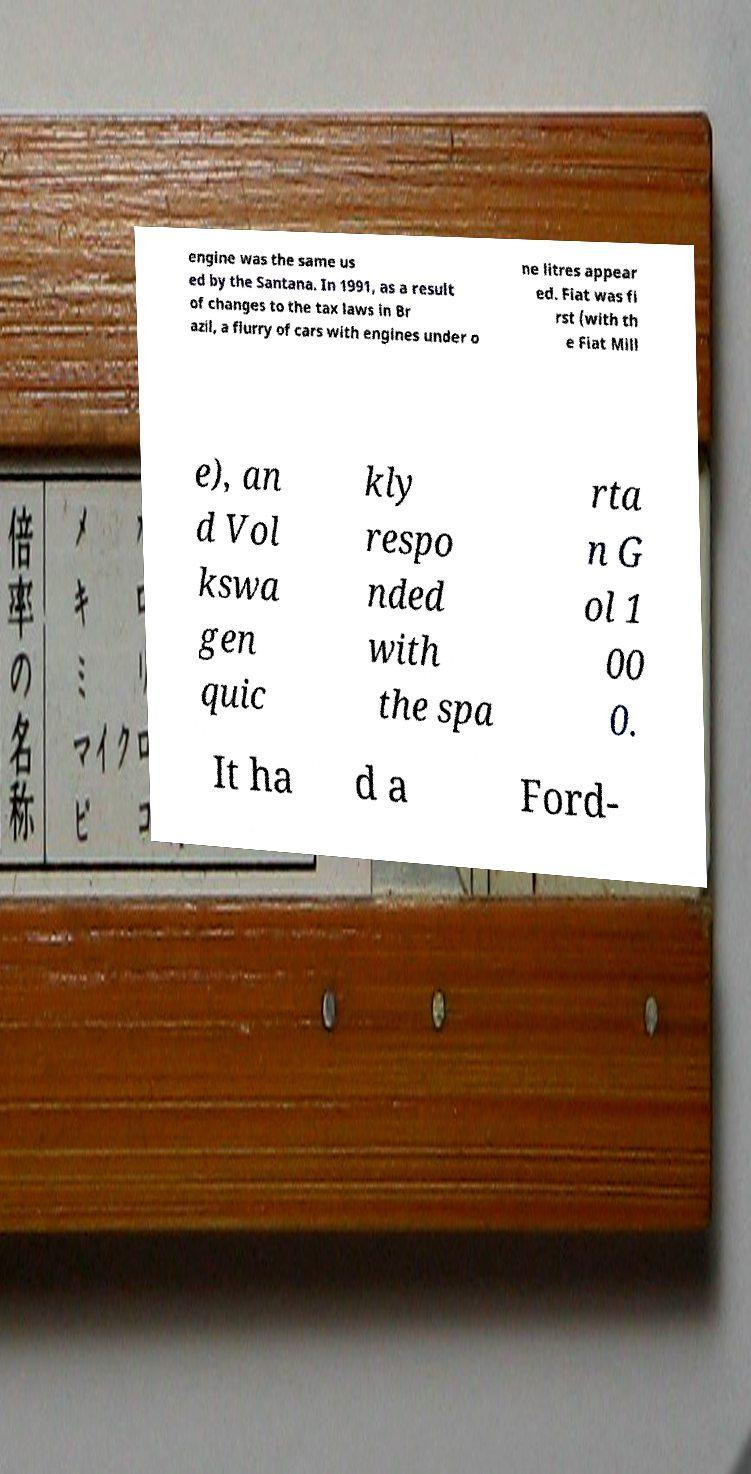Can you read and provide the text displayed in the image?This photo seems to have some interesting text. Can you extract and type it out for me? engine was the same us ed by the Santana. In 1991, as a result of changes to the tax laws in Br azil, a flurry of cars with engines under o ne litres appear ed. Fiat was fi rst (with th e Fiat Mill e), an d Vol kswa gen quic kly respo nded with the spa rta n G ol 1 00 0. It ha d a Ford- 